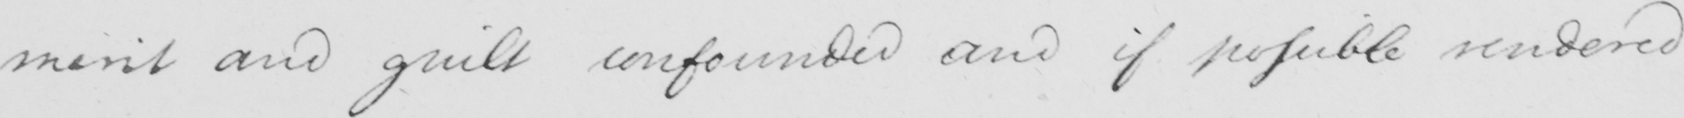Can you tell me what this handwritten text says? merit and guilt confounded and if possible rendered 